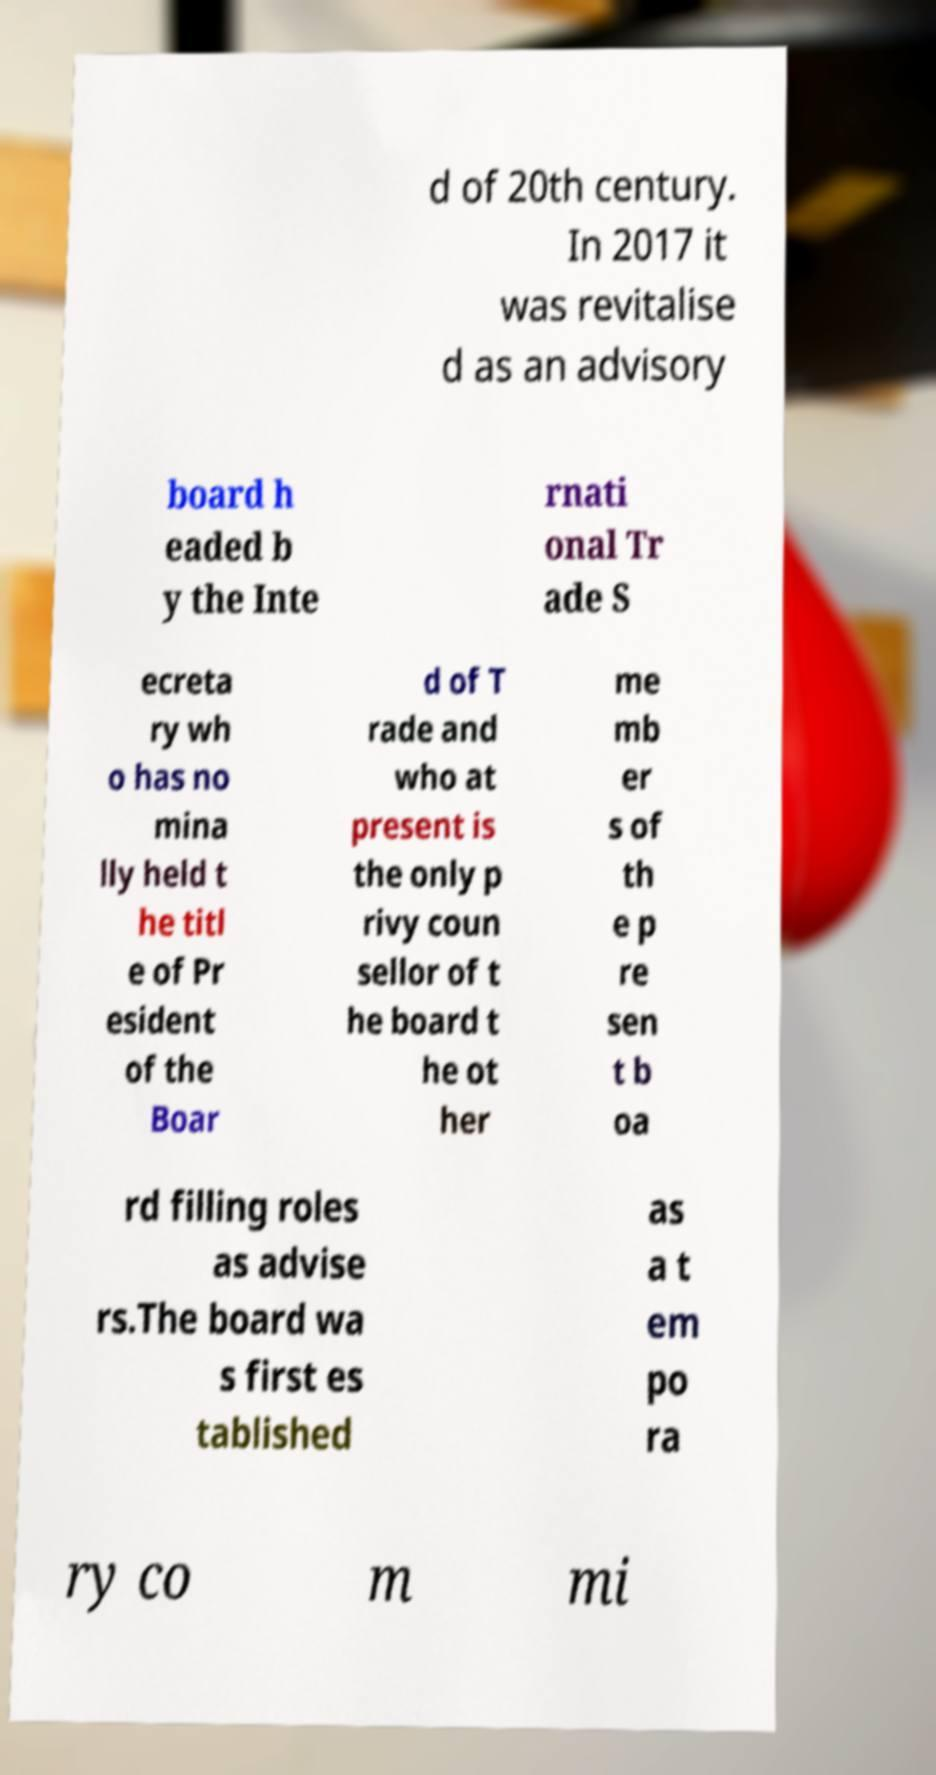Please identify and transcribe the text found in this image. d of 20th century. In 2017 it was revitalise d as an advisory board h eaded b y the Inte rnati onal Tr ade S ecreta ry wh o has no mina lly held t he titl e of Pr esident of the Boar d of T rade and who at present is the only p rivy coun sellor of t he board t he ot her me mb er s of th e p re sen t b oa rd filling roles as advise rs.The board wa s first es tablished as a t em po ra ry co m mi 